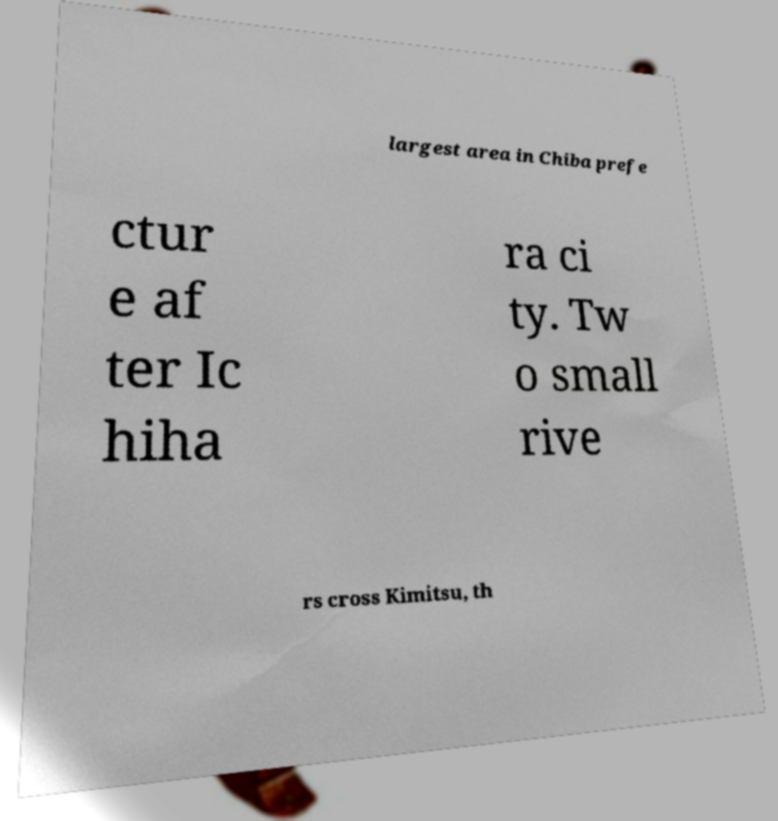Please read and relay the text visible in this image. What does it say? largest area in Chiba prefe ctur e af ter Ic hiha ra ci ty. Tw o small rive rs cross Kimitsu, th 